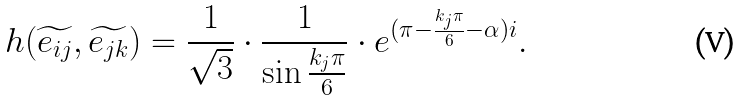<formula> <loc_0><loc_0><loc_500><loc_500>h ( \widetilde { e _ { i j } } , \widetilde { e _ { j k } } ) = \frac { 1 } { \sqrt { 3 } } \cdot \frac { 1 } { \sin \frac { k _ { j } \pi } { 6 } } \cdot e ^ { ( \pi - \frac { k _ { j } \pi } { 6 } - \alpha ) i } .</formula> 